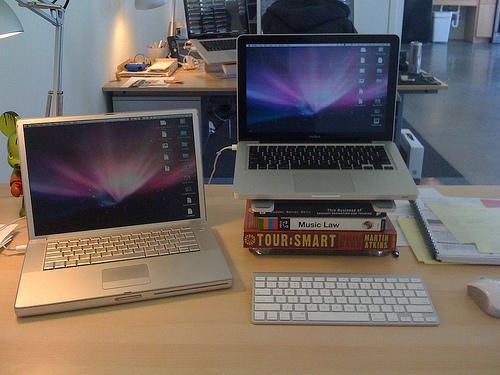How many desks are there?
Give a very brief answer. 2. 